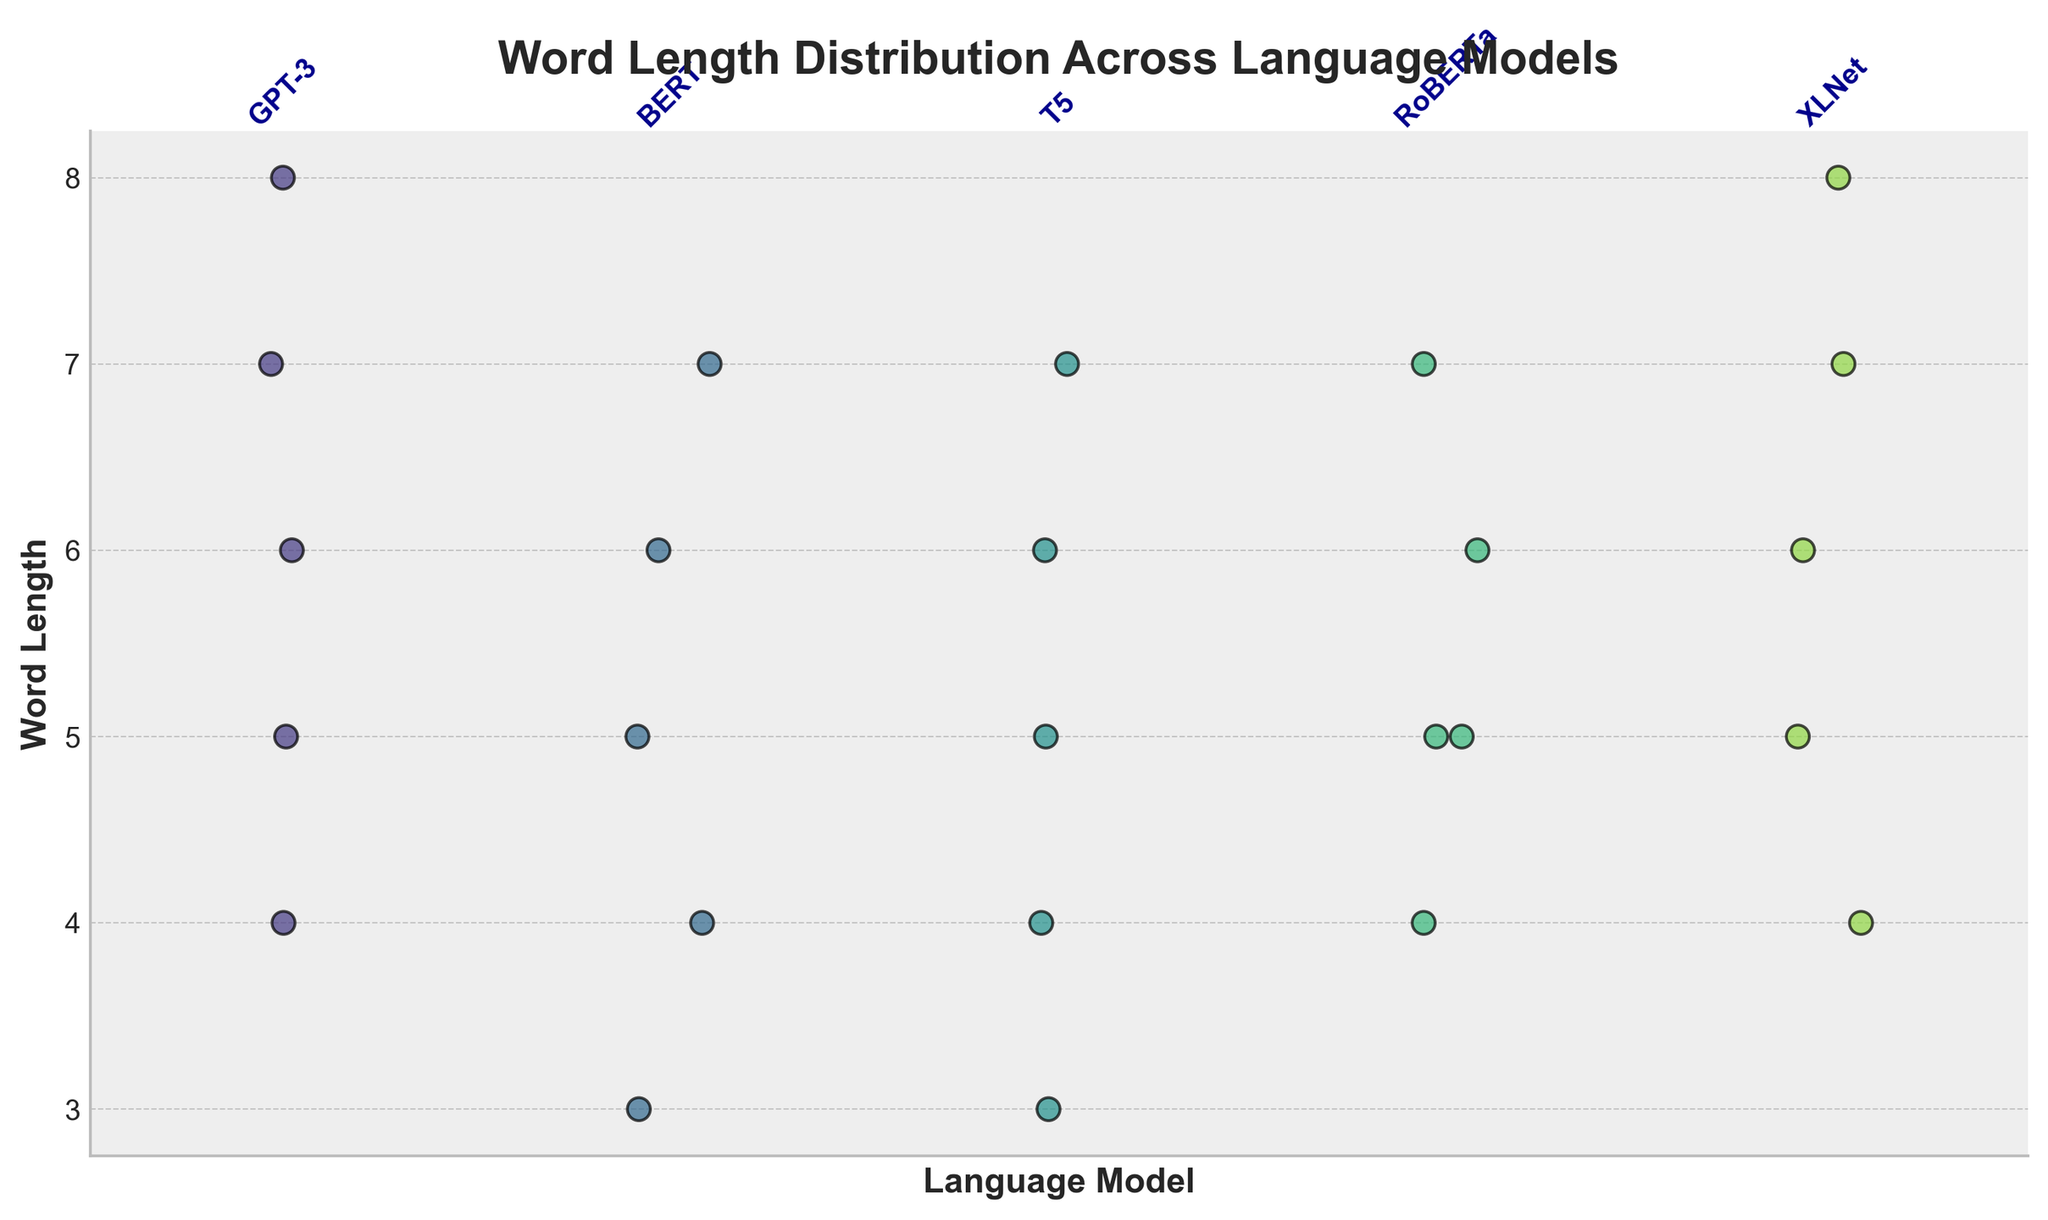What is the title of the figure? The title of the figure is usually displayed at the top of the plot in a larger and bolder font for easy identification. Here, it clearly states the main focus of the plot.
Answer: Word Length Distribution Across Language Models Which language model has the widest range of word lengths? By observing the dispersion of data points along the y-axis for each language model, we can see which model has the most spread-out points, indicating a wider range.
Answer: XLNet How many data points are plotted for the GPT-3 model? We can count the number of individual dots in the strip corresponding to the GPT-3 label on the x-axis.
Answer: 5 What is the maximum word length observed in the BERT model? The highest point among the dots aligned with the BERT label on the x-axis gives us the maximum word length.
Answer: 7 Which models share the same maximum word length of 8? The dots at the maximum value of 8 on the y-axis are checked for their respective models to identify which ones have this common maximum length.
Answer: GPT-3, XLNet Compare the median word length of GPT-3 and T5. Which one has a higher median? The median word length for each model is identified by noting the middle value of the ordered data points. We compare these median values visually.
Answer: GPT-3 How does the distribution of word lengths for RoBERTa compare to T5? Observing the spread and concentration of the dots for RoBERTa and T5 helps us compare their distributions. Both central tendency and variability need to be considered.
Answer: RoBERTa has fewer shorter words and more consistent middle-range lengths What are the unique word lengths generated by the T5 model? Each distinct value along the y-axis for the T5 label gives the unique word lengths.
Answer: 3, 4, 5, 6, 7 